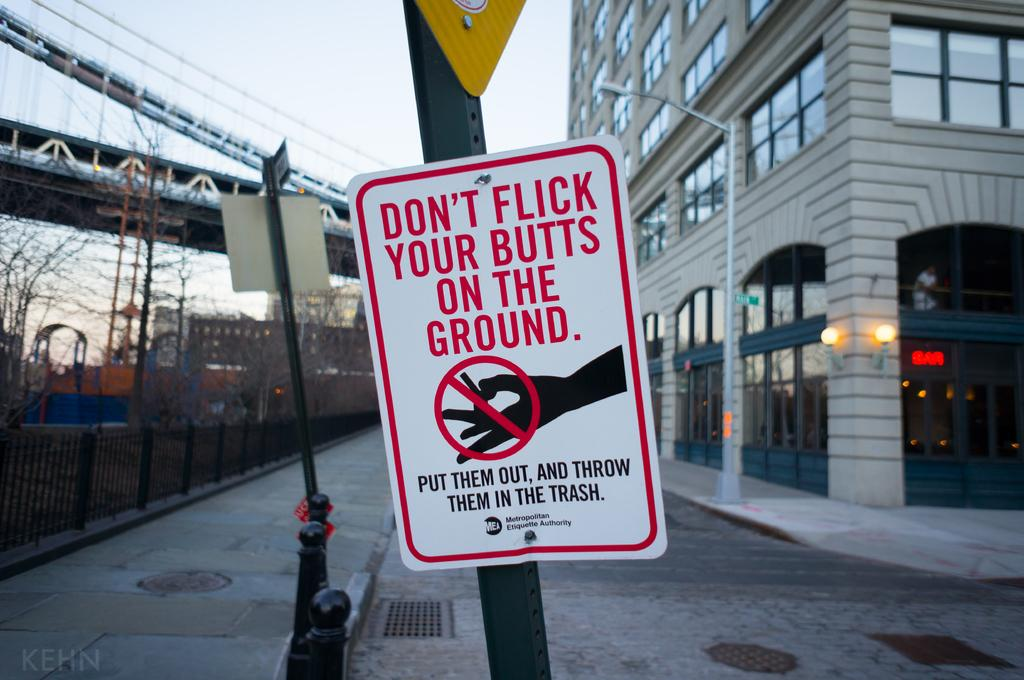<image>
Share a concise interpretation of the image provided. Anti littering poster to not flick your butts on the ground, throw them in the trash instead. 